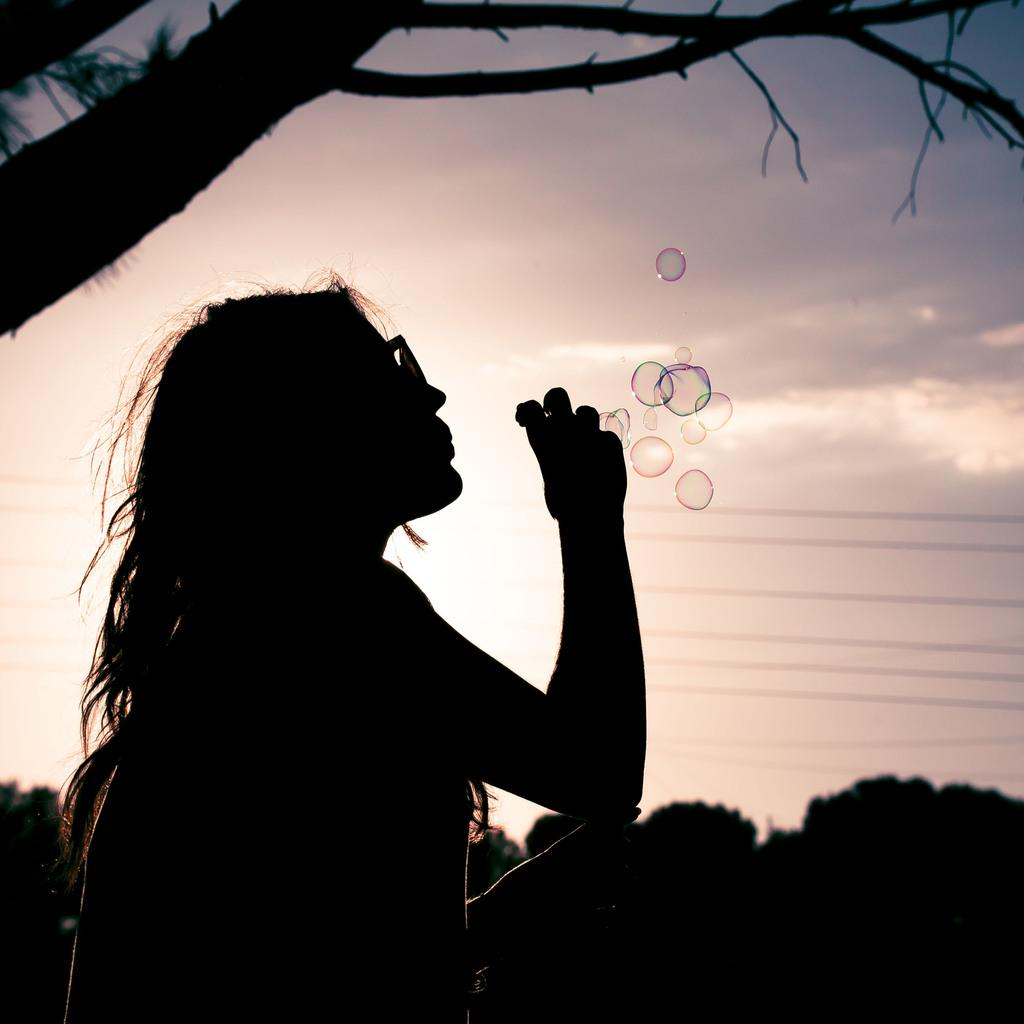Who is the main subject in the image? There is a woman in the image. What is the woman doing in the image? The woman is blowing bubbles. Can you describe the background of the image? The background of the image is blurred. Is there a yak present in the image? No, there is no yak present in the image. Does the existence of the woman in the image prove the existence of extraterrestrial life? No, the existence of the woman in the image does not prove the existence of extraterrestrial life. 